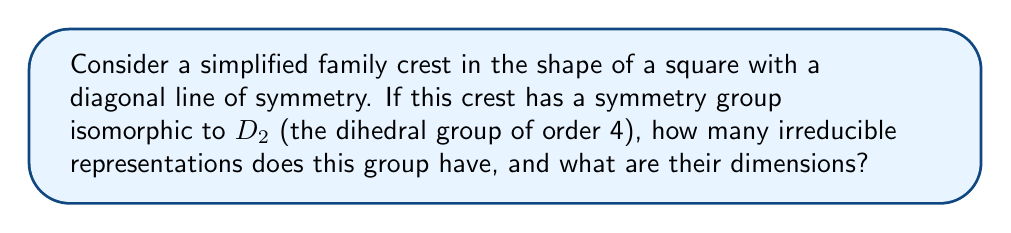Help me with this question. To solve this problem, we'll follow these steps:

1) First, recall that $D_2$ is the symmetry group of a rectangle, which has 4 elements:
   - Identity (e)
   - 180° rotation (r)
   - Reflection across the horizontal axis (h)
   - Reflection across the vertical axis (v)

2) The number of irreducible representations of a finite group is equal to the number of conjugacy classes in the group. Let's find the conjugacy classes of $D_2$:
   - {e} (identity is always in its own class)
   - {r} (r commutes with all elements, so it's in its own class)
   - {h, v} (h and v are conjugate to each other)

3) Therefore, $D_2$ has 3 conjugacy classes, so it will have 3 irreducible representations.

4) To find the dimensions of these representations, we can use the fact that the sum of the squares of the dimensions of irreducible representations must equal the order of the group:

   $$ d_1^2 + d_2^2 + d_3^2 = |D_2| = 4 $$

5) Given that $D_2$ is abelian (all elements commute), all its irreducible representations must be 1-dimensional.

6) Therefore, the only solution to the equation in step 4 is:

   $$ 1^2 + 1^2 + 1^2 = 4 $$

Thus, $D_2$ has three 1-dimensional irreducible representations.
Answer: 3 irreducible representations, all 1-dimensional 